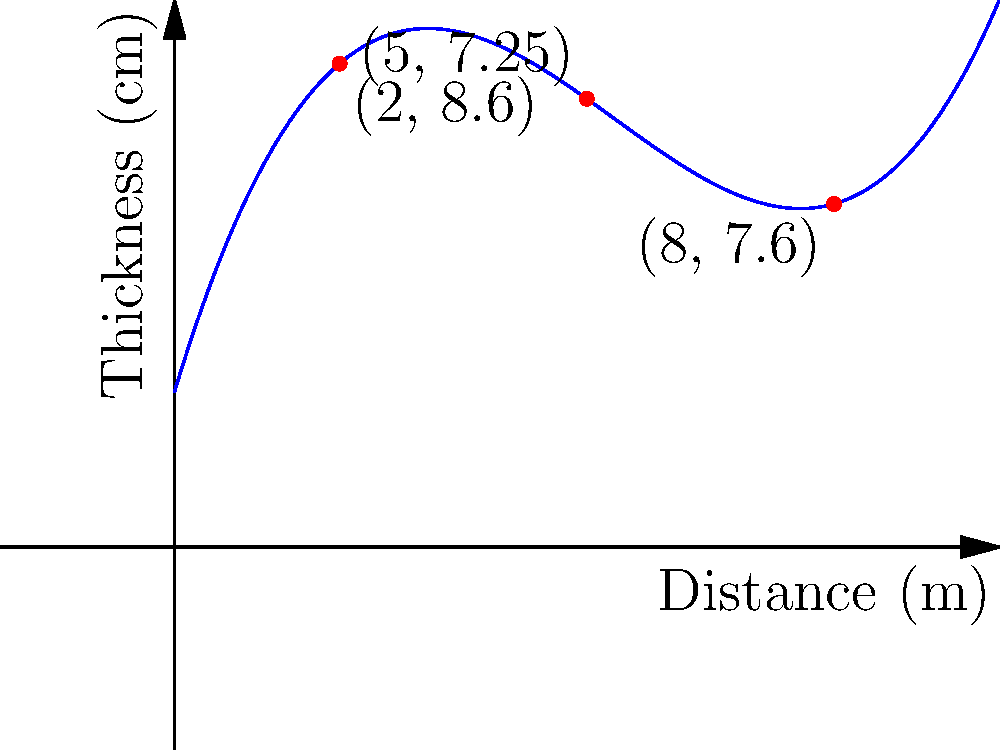As a museum curator specializing in rock and mineral exhibits, you're collaborating with a local mining company to create an educational display about mineral vein thickness prediction. The company has provided data on the thickness of a quartz vein along a mine shaft, which can be modeled by the polynomial function $f(x) = 0.05x^3 - 0.8x^2 + 3.5x + 2$, where $x$ is the distance in meters from the shaft entrance and $f(x)$ is the vein thickness in centimeters. What is the predicted thickness of the quartz vein at a distance of 6 meters from the shaft entrance? To find the predicted thickness of the quartz vein at a distance of 6 meters, we need to evaluate the given polynomial function at $x = 6$. Let's break it down step-by-step:

1) The function is $f(x) = 0.05x^3 - 0.8x^2 + 3.5x + 2$

2) We need to calculate $f(6)$:
   $f(6) = 0.05(6^3) - 0.8(6^2) + 3.5(6) + 2$

3) Let's evaluate each term:
   - $0.05(6^3) = 0.05(216) = 10.8$
   - $-0.8(6^2) = -0.8(36) = -28.8$
   - $3.5(6) = 21$
   - The constant term is 2

4) Now, let's sum all these terms:
   $f(6) = 10.8 - 28.8 + 21 + 2 = 5$

Therefore, the predicted thickness of the quartz vein at a distance of 6 meters from the shaft entrance is 5 centimeters.
Answer: 5 cm 